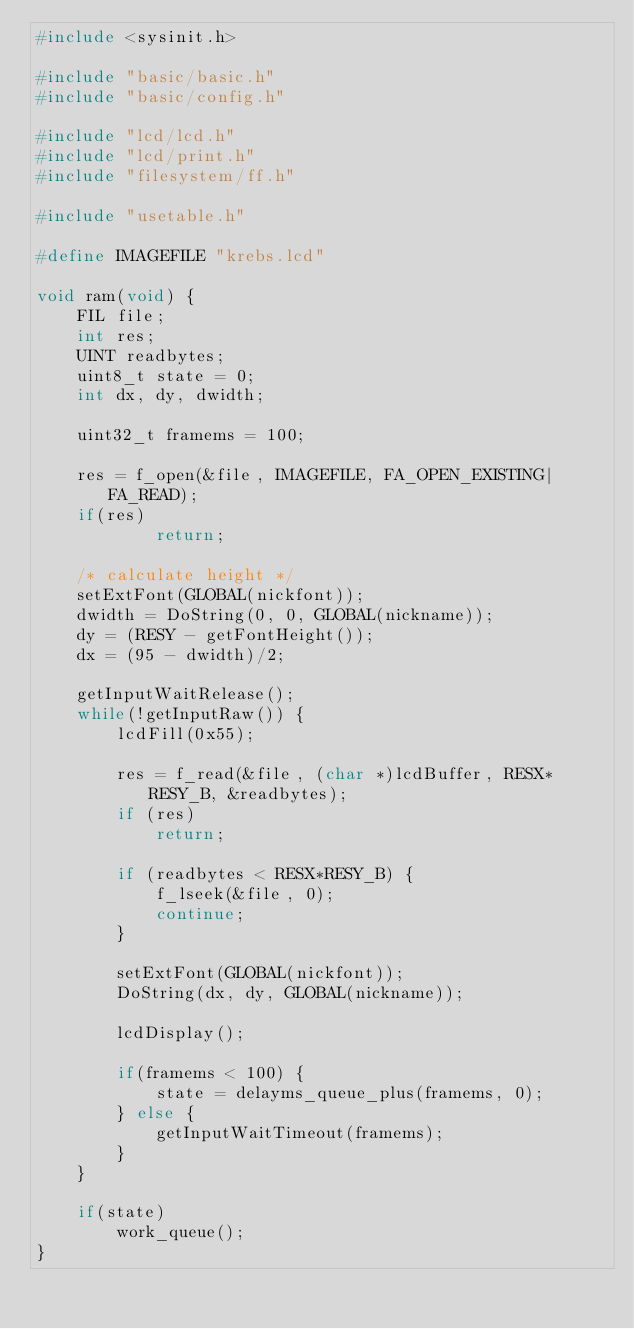<code> <loc_0><loc_0><loc_500><loc_500><_C_>#include <sysinit.h>

#include "basic/basic.h"
#include "basic/config.h"

#include "lcd/lcd.h"
#include "lcd/print.h"
#include "filesystem/ff.h"

#include "usetable.h"

#define IMAGEFILE "krebs.lcd"

void ram(void) {
    FIL file;
    int res;
    UINT readbytes;
    uint8_t state = 0;
    int dx, dy, dwidth;

    uint32_t framems = 100;

    res = f_open(&file, IMAGEFILE, FA_OPEN_EXISTING|FA_READ);
    if(res)
            return;

    /* calculate height */
    setExtFont(GLOBAL(nickfont));
    dwidth = DoString(0, 0, GLOBAL(nickname));
    dy = (RESY - getFontHeight());
    dx = (95 - dwidth)/2;

    getInputWaitRelease();
    while(!getInputRaw()) {
        lcdFill(0x55);

        res = f_read(&file, (char *)lcdBuffer, RESX*RESY_B, &readbytes);
        if (res)
            return;

        if (readbytes < RESX*RESY_B) {
            f_lseek(&file, 0);
            continue;
        }

        setExtFont(GLOBAL(nickfont));
        DoString(dx, dy, GLOBAL(nickname));

        lcdDisplay();

        if(framems < 100) {
            state = delayms_queue_plus(framems, 0);
        } else {
            getInputWaitTimeout(framems);
        }
    }

    if(state)
        work_queue();
}
</code> 